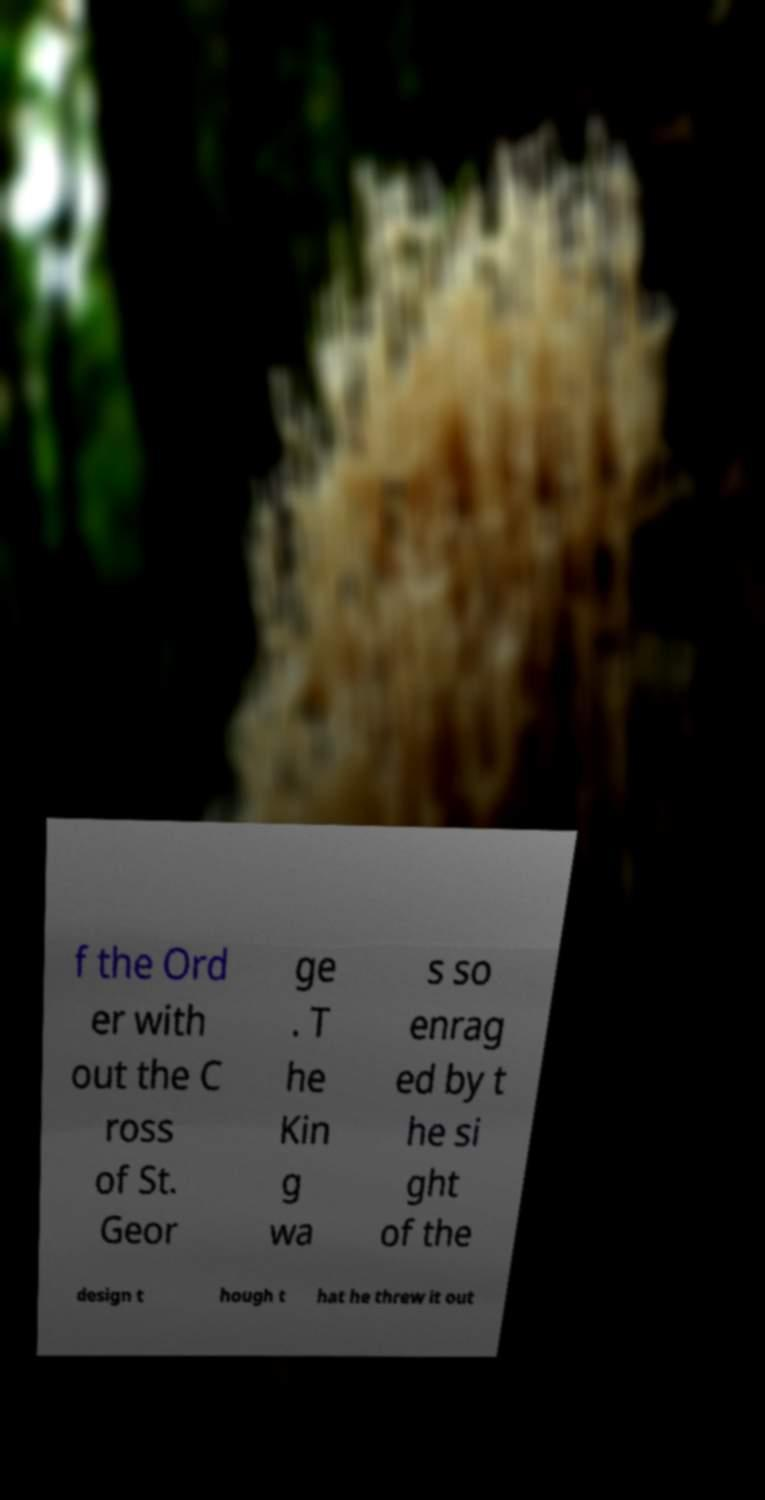For documentation purposes, I need the text within this image transcribed. Could you provide that? f the Ord er with out the C ross of St. Geor ge . T he Kin g wa s so enrag ed by t he si ght of the design t hough t hat he threw it out 